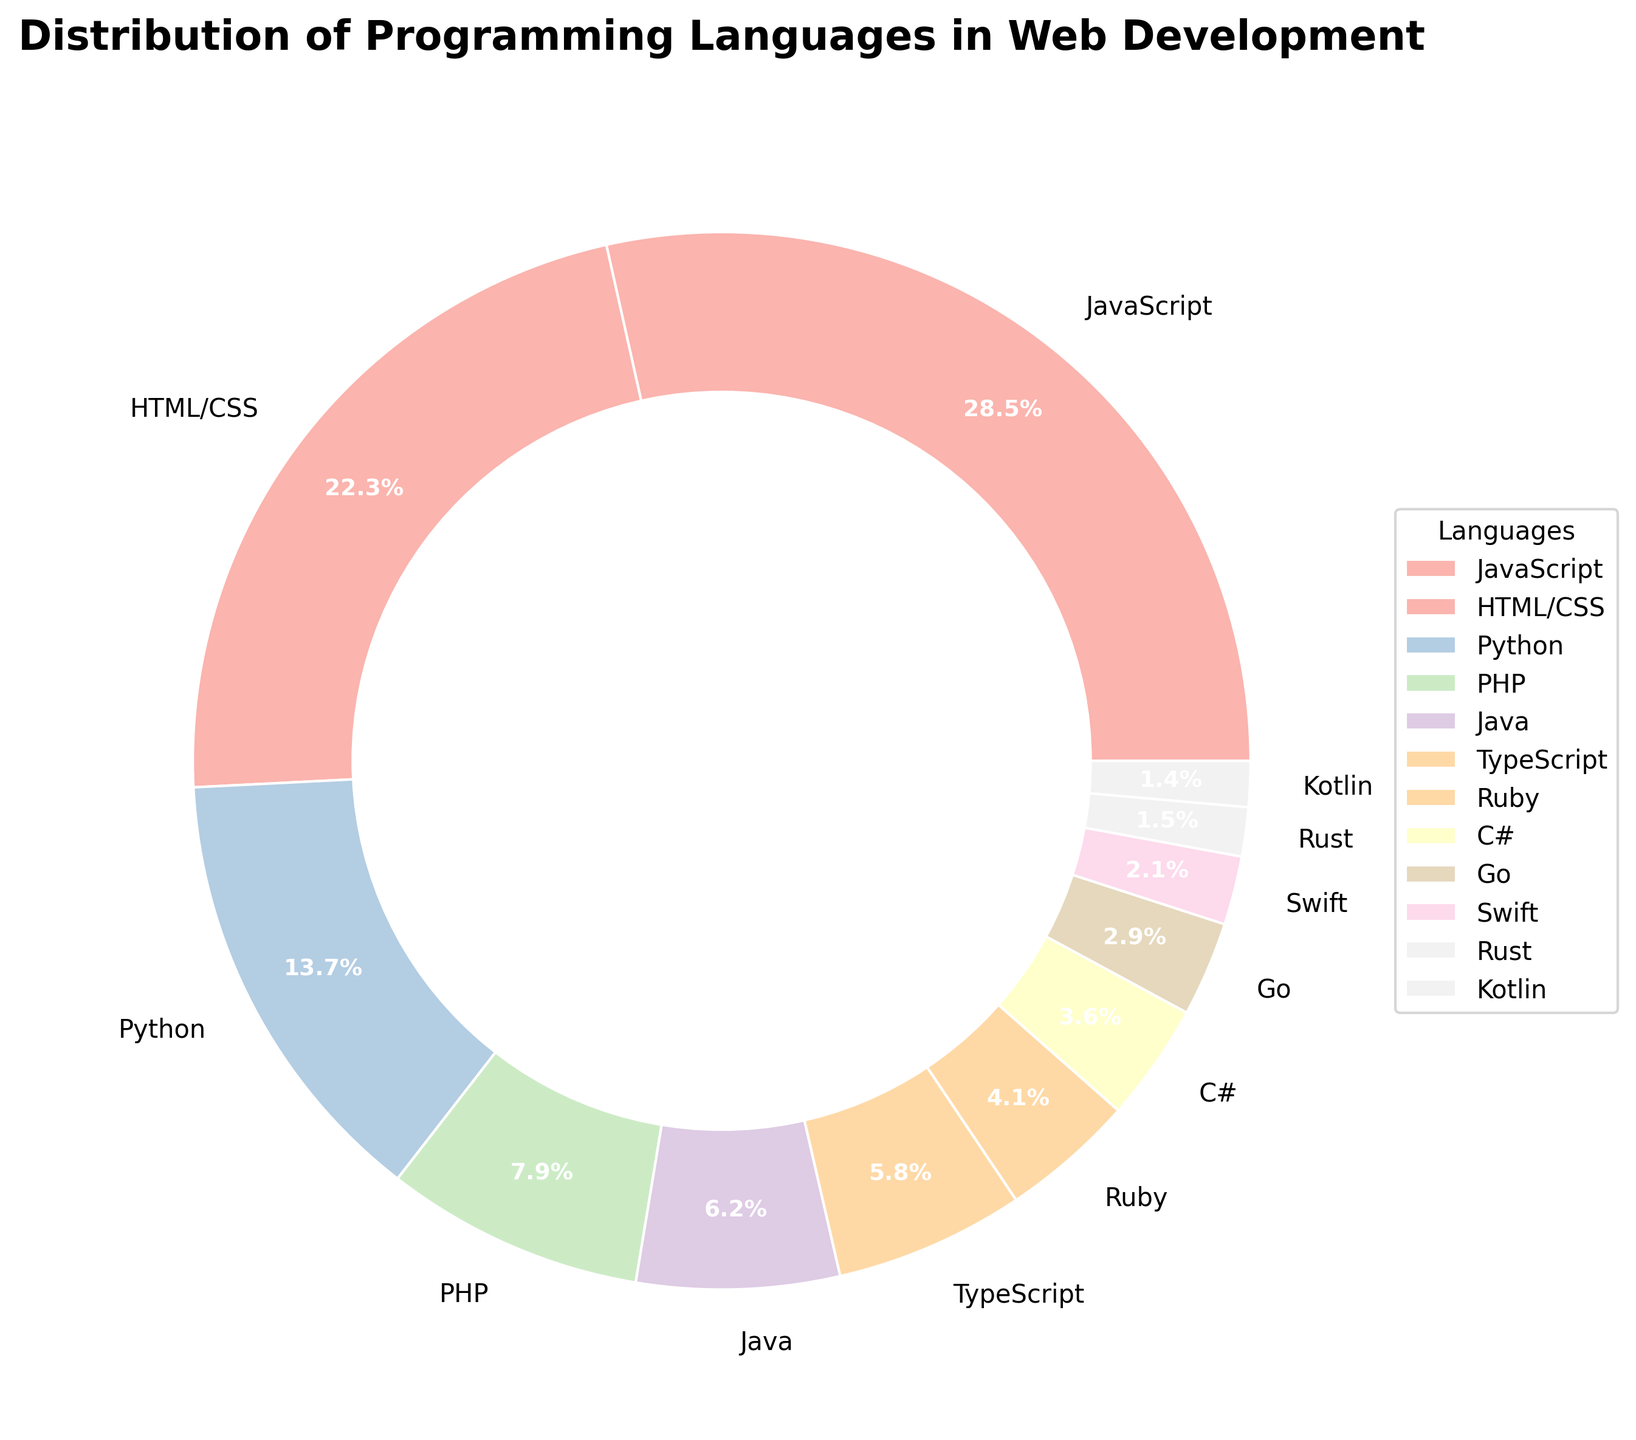Which programming language has the largest usage percentage in web development? The pie chart shows the distribution of programming languages used in web development. The largest segment of the pie chart belongs to JavaScript, indicated as 28.5%.
Answer: JavaScript Which two languages combined have a percentage closest to 30%? The percentages of HTML/CSS and Python are 22.3% and 13.7%, respectively. Adding these gives 36%, which is larger than 30%. The next highest languages are PHP (7.9%) and Java (6.2%), adding to 14.1%. PHP and TypeScript combine to 13.7%. Java (6.2%) and TypeScript (5.8%) sum to 12%. JavaScript (28.5%) plus TypeScript (5.8%) totals 34.3%. The optimal pair is thus Java (6.2%) and PHP (7.9%), summing to 14.1%, since no immediate closer pair exists.
Answer: Java and PHP Which language has a usage percentage closest to 5%? Visual inspection of the segments indicates that TypeScript has a percentage of 5.8%, which is the closest to 5%.
Answer: TypeScript Sum the percentages of the three least used languages in web development. The percentages for the least used languages are Rust (1.5%), Kotlin (1.4%), and Swift (2.1%). Summing these gives 1.5 + 1.4 + 2.1 = 5.0%.
Answer: 5.0% Which language is more popular, Ruby or C#? Ruby has a segment indicating a percentage of 4.1%, whereas C# has a segment with a smaller percentage of 3.6%. Therefore, Ruby is more popular than C#.
Answer: Ruby How many languages have a usage percentage of over 10%? Based on the pie chart, JavaScript (28.5%), HTML/CSS (22.3%), and Python (13.7%) are the only languages with percentages exceeding 10%. Counting these three, we get a total of three languages.
Answer: 3 Is the sum of the percentages of Java and TypeScript greater than that of Python? The given percentages are Java (6.2%) and TypeScript (5.8%). Summing these gives 6.2 + 5.8 = 12.0%. Python has a percentage of 13.7%. Thus, 12.0% is less than 13.7%.
Answer: No What percentage of web development usage do JavaScript, HTML/CSS, and Python constitute together? Adding the percentages of JavaScript (28.5%), HTML/CSS (22.3%), and Python (13.7%) results in a sum of 28.5 + 22.3 + 13.7 = 64.5%.
Answer: 64.5% Compare the percentage usage of Go and Swift; which one is higher? Go has a segment with a percentage of 2.9%, while Swift has a smaller segment with a percentage of 2.1%. This indicates that Go has a higher usage percentage than Swift.
Answer: Go 